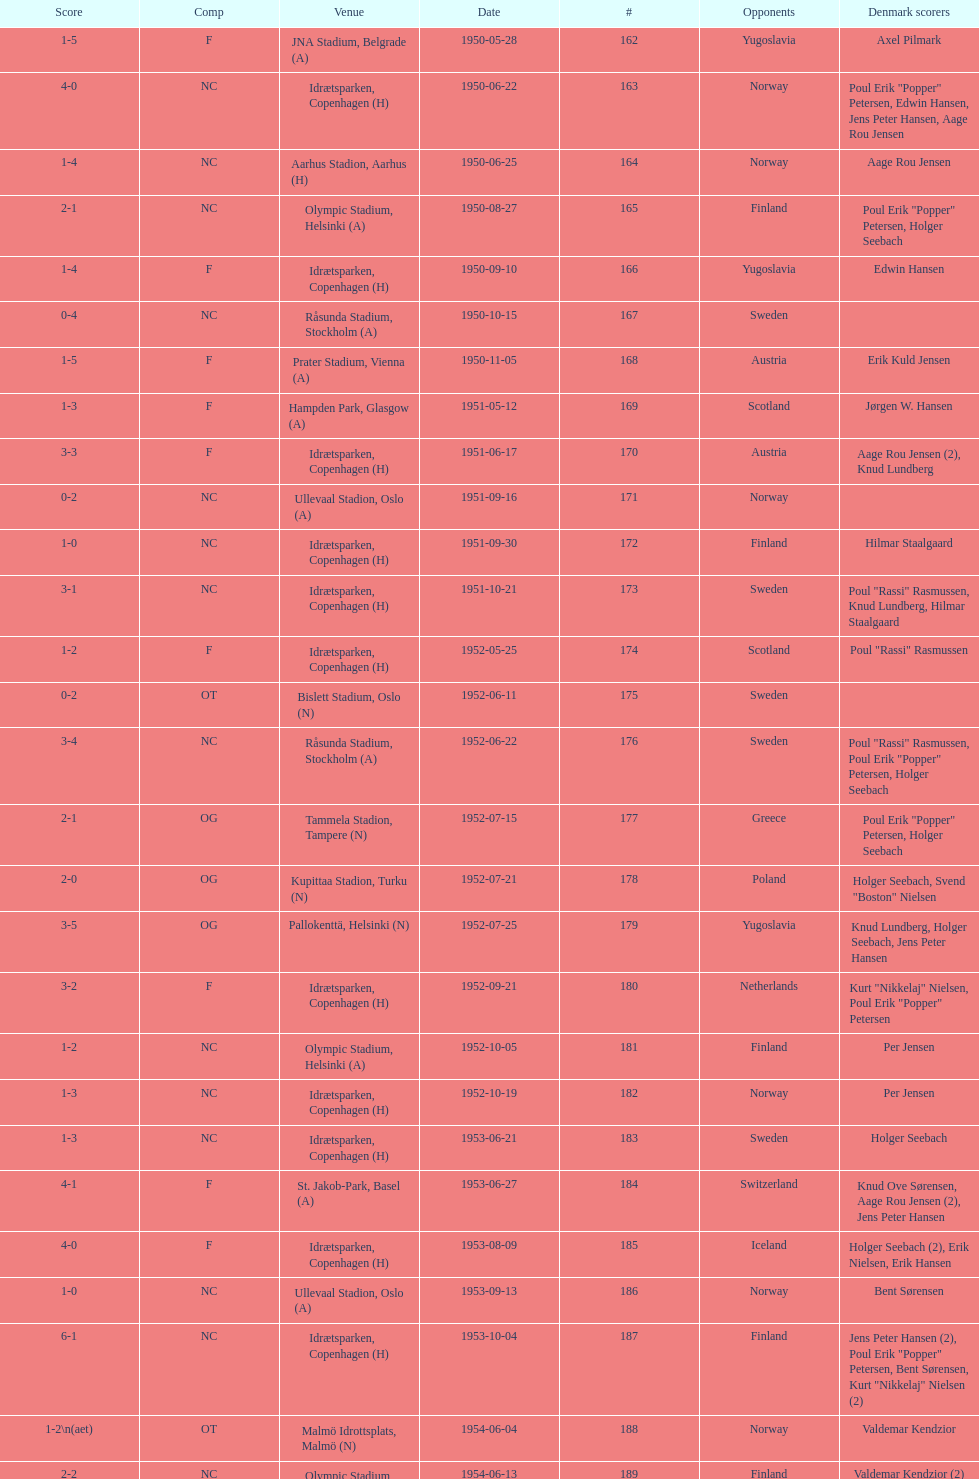What are the number of times nc appears under the comp column? 32. 